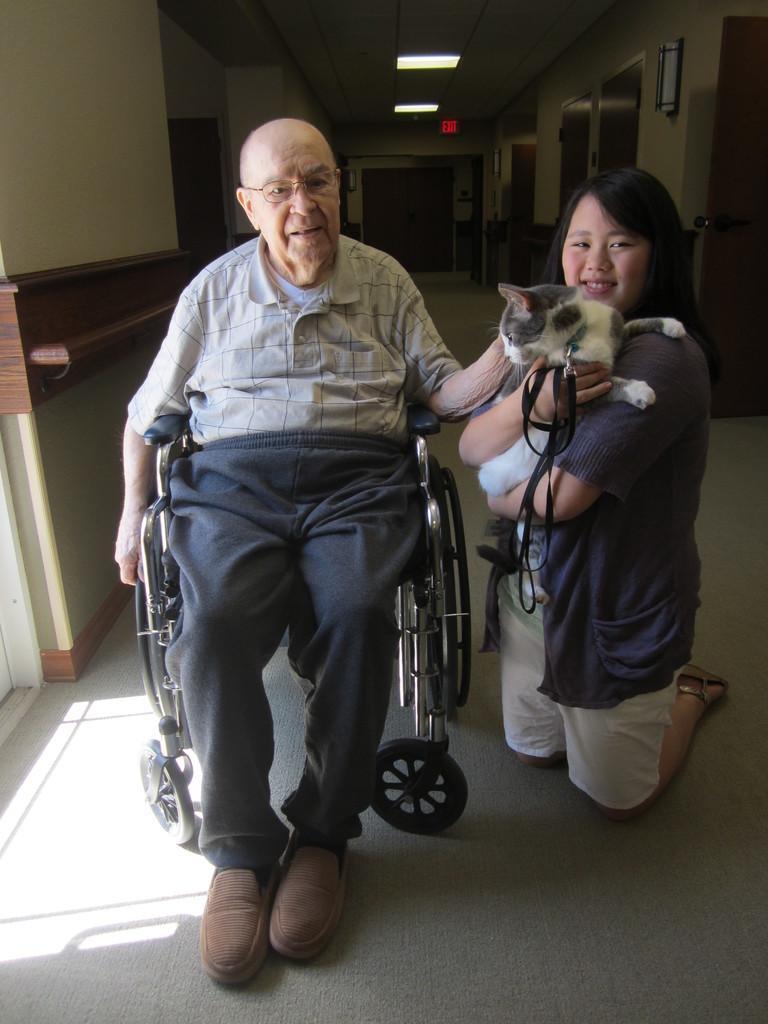Please provide a concise description of this image. In this image I can see two people and one person is holding the cat. These people are wearing the different color dresses and the cat is in white and black color. One person is sitting on the wheelchair. In the back I can see the lights and the doors. 